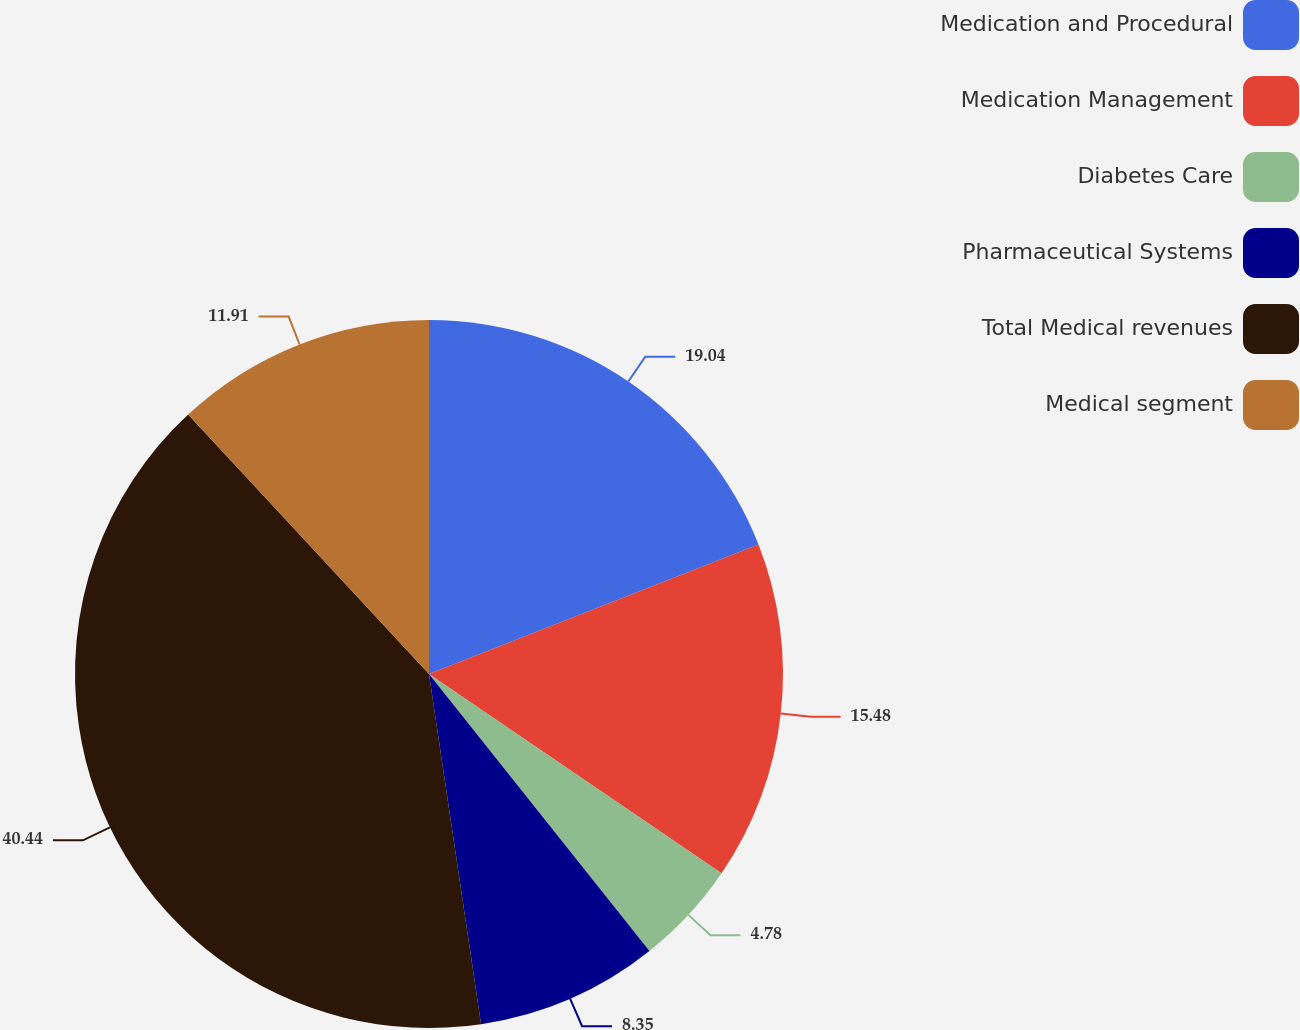Convert chart to OTSL. <chart><loc_0><loc_0><loc_500><loc_500><pie_chart><fcel>Medication and Procedural<fcel>Medication Management<fcel>Diabetes Care<fcel>Pharmaceutical Systems<fcel>Total Medical revenues<fcel>Medical segment<nl><fcel>19.04%<fcel>15.48%<fcel>4.78%<fcel>8.35%<fcel>40.44%<fcel>11.91%<nl></chart> 